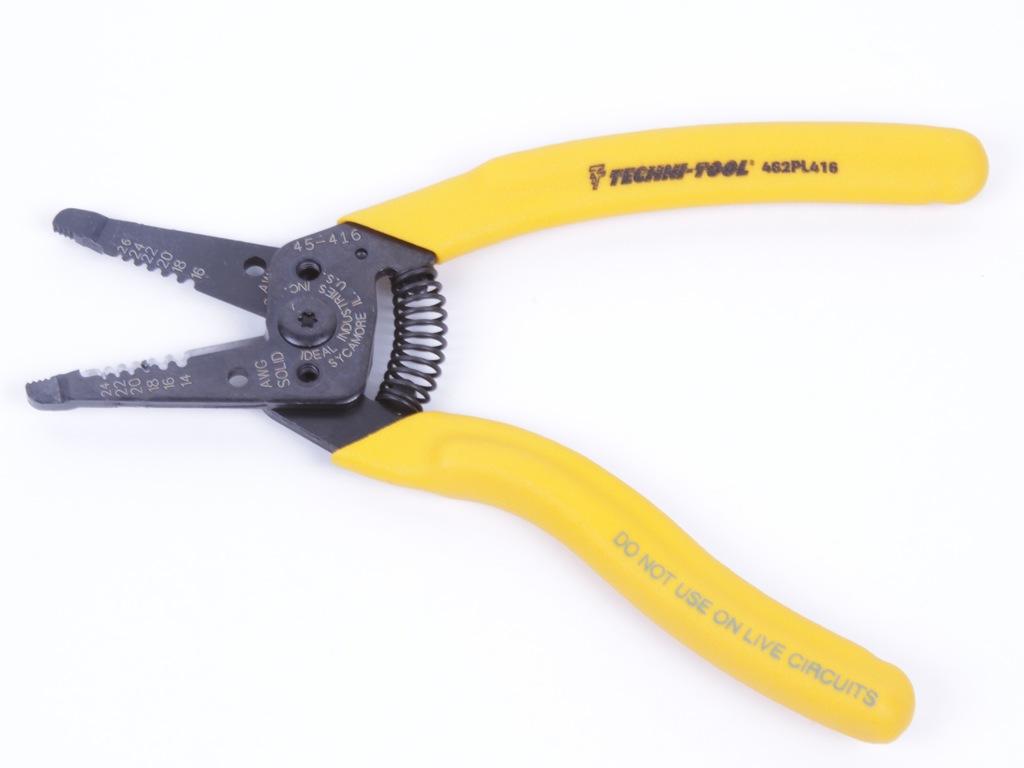What sort of pliers are these?
Ensure brevity in your answer.  Techni-tool. What is the warning on the handle?
Provide a succinct answer. Do not use on live circuits. 